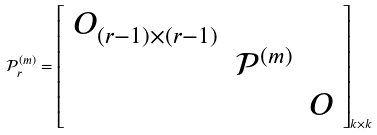<formula> <loc_0><loc_0><loc_500><loc_500>\mathcal { P } ^ { ( m ) } _ { r } = \left [ \begin{array} { r r r } O _ { ( r - 1 ) \times ( r - 1 ) } & & \\ & \mathcal { P } ^ { ( m ) } & \\ & & O \end{array} \right ] _ { k \times k }</formula> 